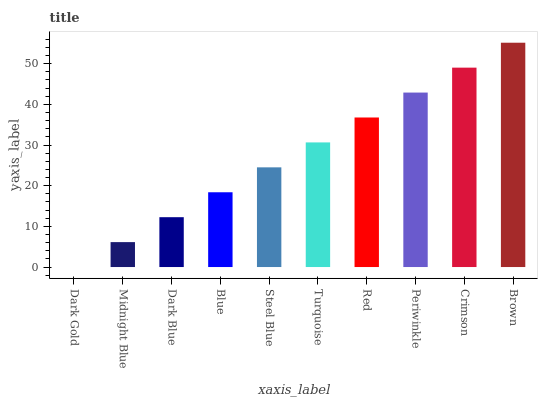Is Dark Gold the minimum?
Answer yes or no. Yes. Is Brown the maximum?
Answer yes or no. Yes. Is Midnight Blue the minimum?
Answer yes or no. No. Is Midnight Blue the maximum?
Answer yes or no. No. Is Midnight Blue greater than Dark Gold?
Answer yes or no. Yes. Is Dark Gold less than Midnight Blue?
Answer yes or no. Yes. Is Dark Gold greater than Midnight Blue?
Answer yes or no. No. Is Midnight Blue less than Dark Gold?
Answer yes or no. No. Is Turquoise the high median?
Answer yes or no. Yes. Is Steel Blue the low median?
Answer yes or no. Yes. Is Steel Blue the high median?
Answer yes or no. No. Is Red the low median?
Answer yes or no. No. 